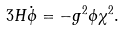Convert formula to latex. <formula><loc_0><loc_0><loc_500><loc_500>3 H \dot { \phi } = - { g ^ { 2 } } \phi \chi ^ { 2 } .</formula> 